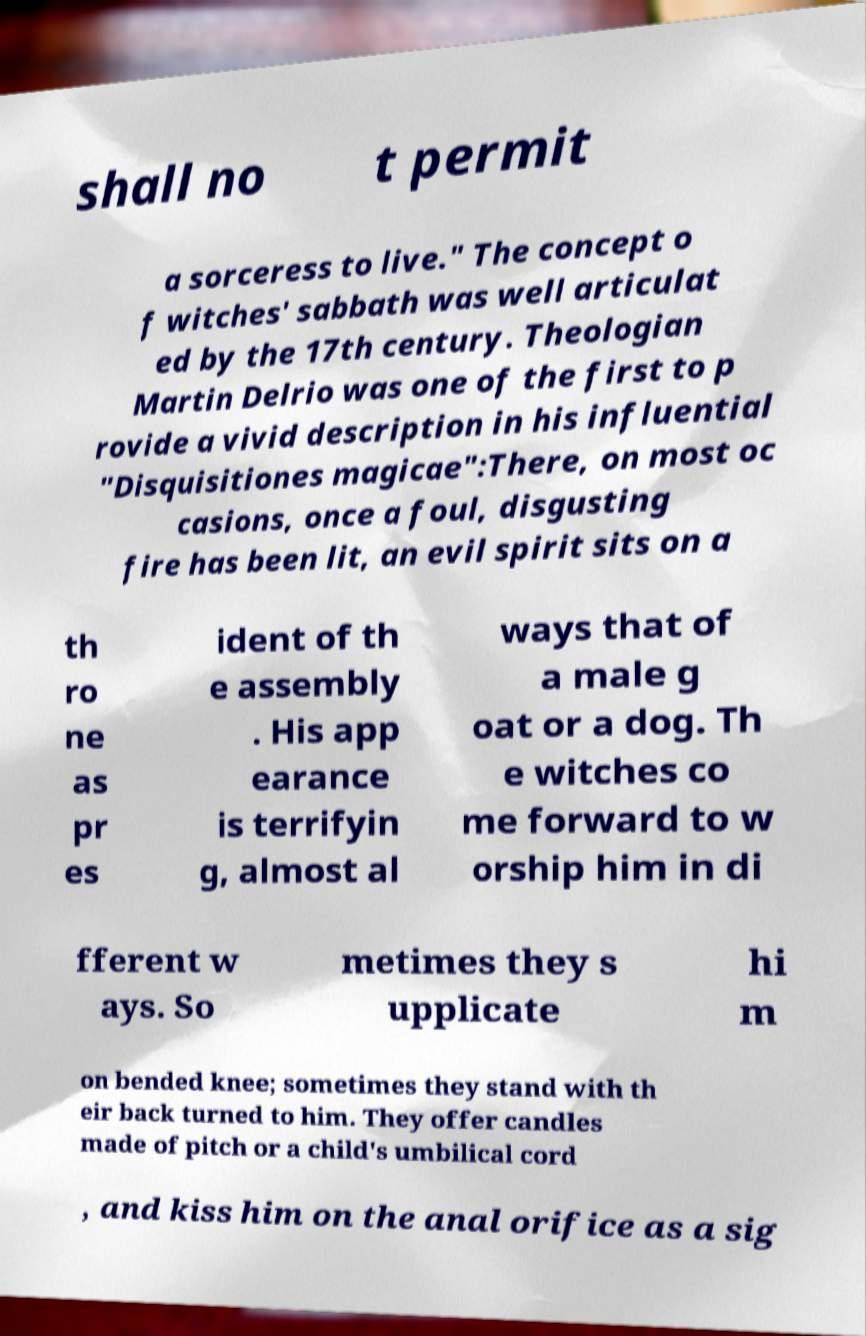Please identify and transcribe the text found in this image. shall no t permit a sorceress to live." The concept o f witches' sabbath was well articulat ed by the 17th century. Theologian Martin Delrio was one of the first to p rovide a vivid description in his influential "Disquisitiones magicae":There, on most oc casions, once a foul, disgusting fire has been lit, an evil spirit sits on a th ro ne as pr es ident of th e assembly . His app earance is terrifyin g, almost al ways that of a male g oat or a dog. Th e witches co me forward to w orship him in di fferent w ays. So metimes they s upplicate hi m on bended knee; sometimes they stand with th eir back turned to him. They offer candles made of pitch or a child's umbilical cord , and kiss him on the anal orifice as a sig 